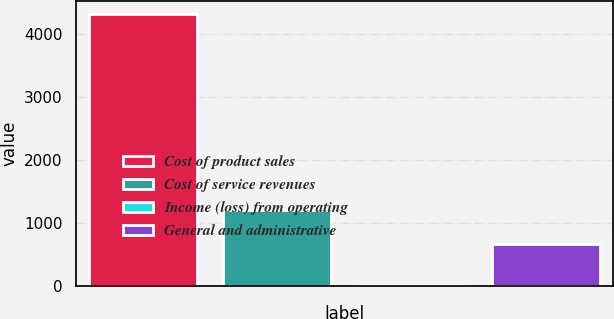Convert chart to OTSL. <chart><loc_0><loc_0><loc_500><loc_500><bar_chart><fcel>Cost of product sales<fcel>Cost of service revenues<fcel>Income (loss) from operating<fcel>General and administrative<nl><fcel>4319<fcel>1198<fcel>10<fcel>669<nl></chart> 